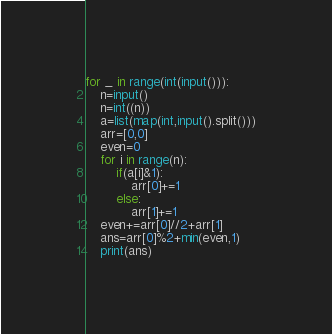<code> <loc_0><loc_0><loc_500><loc_500><_Python_>for _ in range(int(input())):
    n=input()
    n=int((n))
    a=list(map(int,input().split()))
    arr=[0,0]
    even=0
    for i in range(n):
        if(a[i]&1):
            arr[0]+=1
        else:
            arr[1]+=1
    even+=arr[0]//2+arr[1]
    ans=arr[0]%2+min(even,1)
    print(ans) </code> 